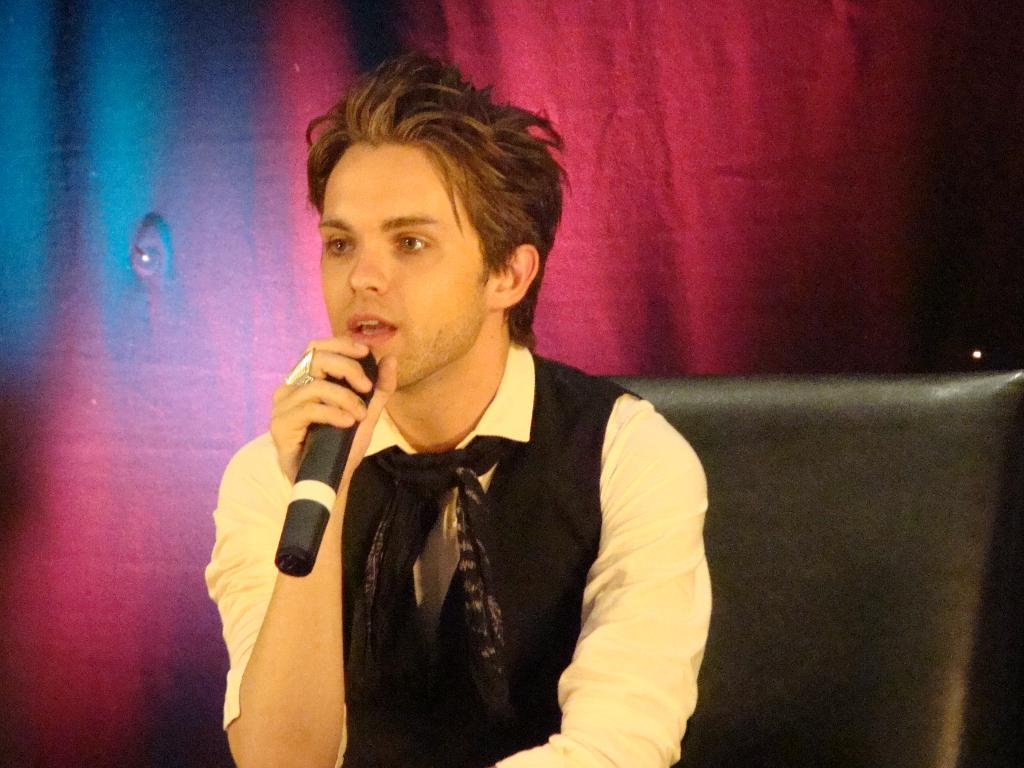What is the man in the image doing? The man is sitting on a chair in the image. What is the man holding in the image? The man is holding a microphone in the image. What is the man wearing in the image? The man is wearing a suit, a shirt, and a scarf in the image. What can be seen hanging in the background of the image? There is a curtain hanging in the image. What song is the man singing in the image? There is no indication in the image that the man is singing, nor is there any information about a song. 